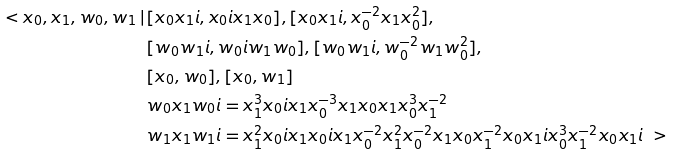<formula> <loc_0><loc_0><loc_500><loc_500>\ < x _ { 0 } , x _ { 1 } , w _ { 0 } , w _ { 1 } \, | \, & [ x _ { 0 } x _ { 1 } \i i , x _ { 0 } \i i x _ { 1 } x _ { 0 } ] , [ x _ { 0 } x _ { 1 } \i i , x _ { 0 } ^ { - 2 } x _ { 1 } x _ { 0 } ^ { 2 } ] , \\ & [ w _ { 0 } w _ { 1 } \i i , w _ { 0 } \i i w _ { 1 } w _ { 0 } ] , [ w _ { 0 } w _ { 1 } \i i , w _ { 0 } ^ { - 2 } w _ { 1 } w _ { 0 } ^ { 2 } ] , \\ & [ x _ { 0 } , w _ { 0 } ] , [ x _ { 0 } , w _ { 1 } ] \\ & w _ { 0 } x _ { 1 } w _ { 0 } \i i = x _ { 1 } ^ { 3 } x _ { 0 } \i i x _ { 1 } x _ { 0 } ^ { - 3 } x _ { 1 } x _ { 0 } x _ { 1 } x _ { 0 } ^ { 3 } x _ { 1 } ^ { - 2 } \\ & w _ { 1 } x _ { 1 } w _ { 1 } \i i = x _ { 1 } ^ { 2 } x _ { 0 } \i i x _ { 1 } x _ { 0 } \i i x _ { 1 } x _ { 0 } ^ { - 2 } x _ { 1 } ^ { 2 } x _ { 0 } ^ { - 2 } x _ { 1 } x _ { 0 } x _ { 1 } ^ { - 2 } x _ { 0 } x _ { 1 } \i i x _ { 0 } ^ { 3 } x _ { 1 } ^ { - 2 } x _ { 0 } x _ { 1 } \i i \ ></formula> 